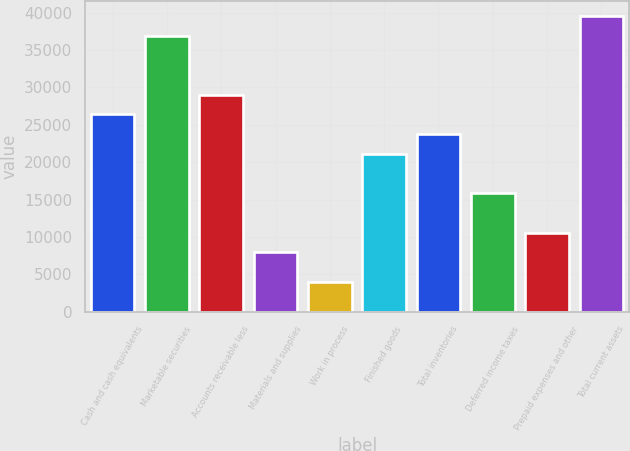Convert chart. <chart><loc_0><loc_0><loc_500><loc_500><bar_chart><fcel>Cash and cash equivalents<fcel>Marketable securities<fcel>Accounts receivable less<fcel>Materials and supplies<fcel>Work in process<fcel>Finished goods<fcel>Total inventories<fcel>Deferred income taxes<fcel>Prepaid expenses and other<fcel>Total current assets<nl><fcel>26396<fcel>36948<fcel>29034<fcel>7930<fcel>3973<fcel>21120<fcel>23758<fcel>15844<fcel>10568<fcel>39586<nl></chart> 